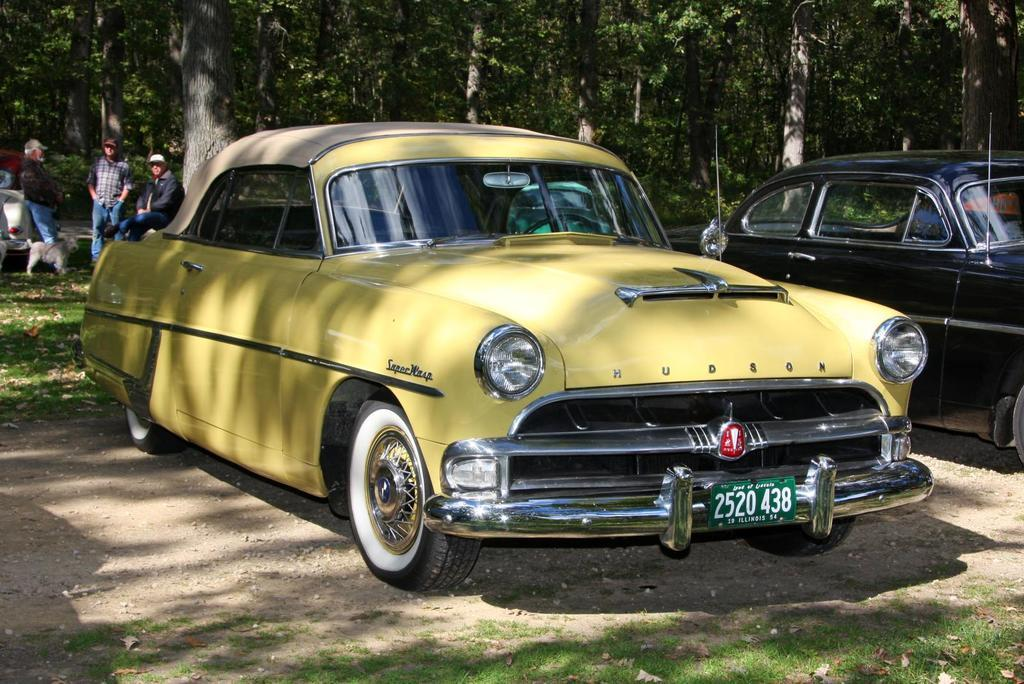What vehicles can be seen in the front of the image? There are two cars in the front of the image. How many people are standing on the left side of the image? There are three persons standing on the left side of the image. What type of terrain are the persons standing on? The persons are standing on grassland. What can be seen in the background of the image? Trees are visible in the background of the image. What type of steel structure can be seen near the coast in the image? There is no steel structure or coast visible in the image; it features two cars and three persons standing on grassland with trees in the background. Can you see an airplane flying over the scene in the image? There is no airplane visible in the image; it only shows two cars, three persons, and trees in the background. 